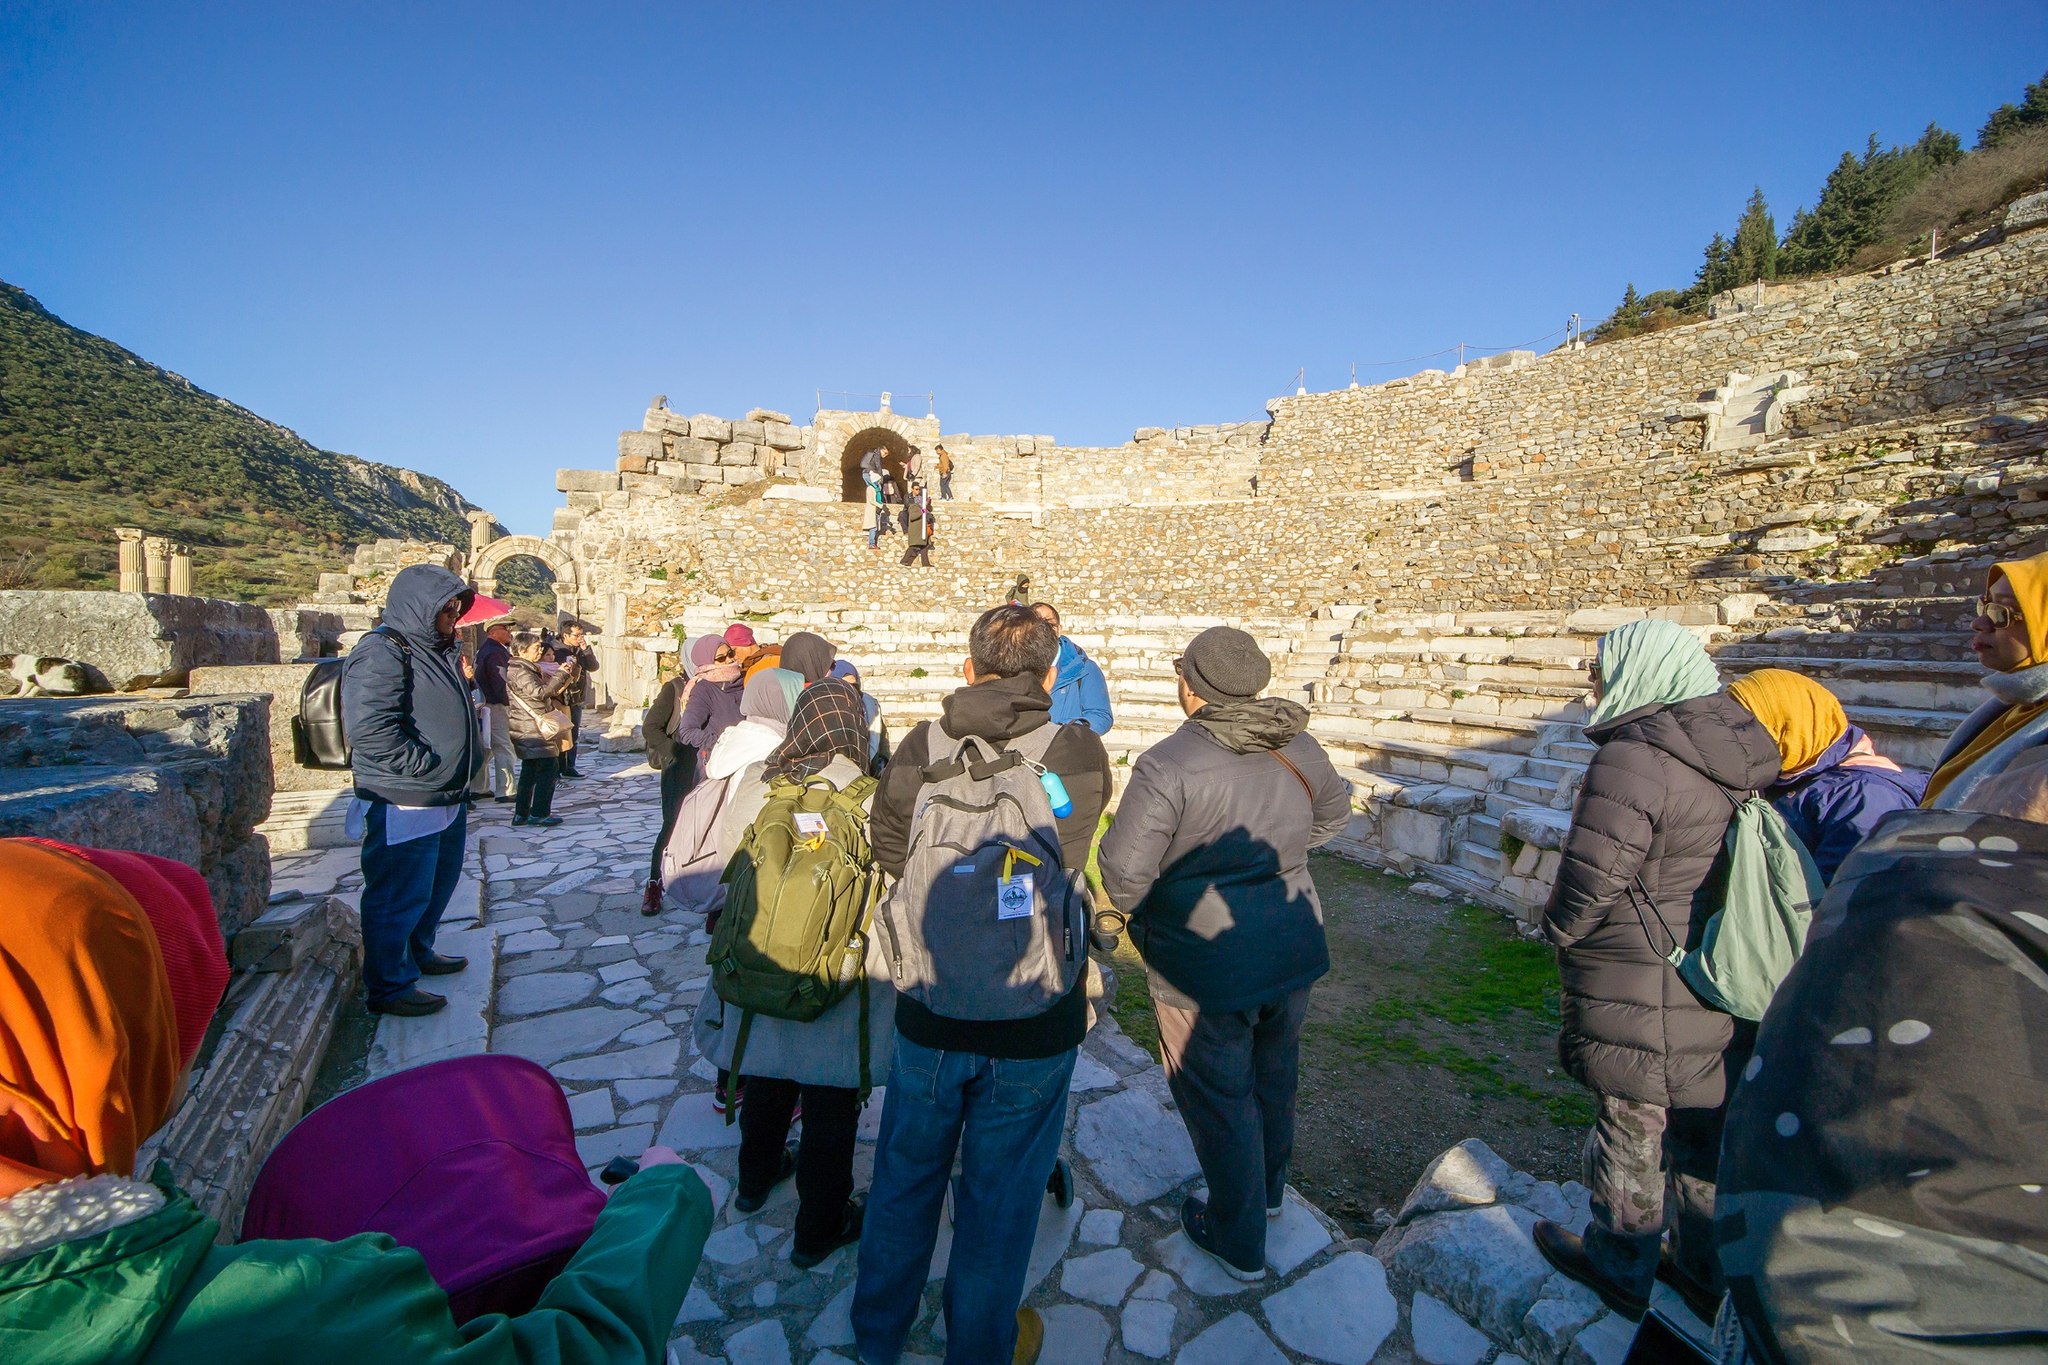What historical significance might this place hold? This site appears to be an ancient ruin, likely dating back to centuries, if not millennia. Such ruins typically hold significant historical value as they provide insights into past civilizations, their architecture, culture, and daily life. The stone archway might have served as an entrance or a gate, symbolizing a transition between different areas of the site. The amphitheater-like stone steps could indicate an area used for gatherings, performances, or public meetings in ancient times. By studying these structures, archaeologists can learn about the construction techniques, materials used, and the social or political functions the site served within its historical context. 